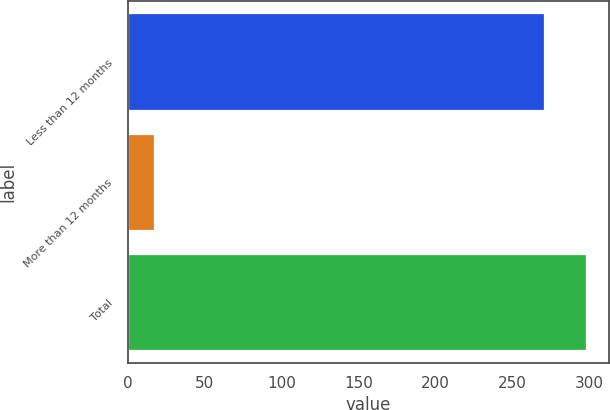<chart> <loc_0><loc_0><loc_500><loc_500><bar_chart><fcel>Less than 12 months<fcel>More than 12 months<fcel>Total<nl><fcel>271<fcel>17<fcel>298.1<nl></chart> 